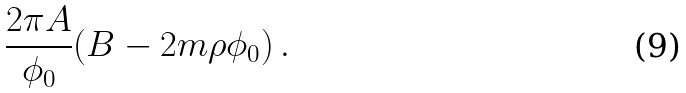Convert formula to latex. <formula><loc_0><loc_0><loc_500><loc_500>\frac { 2 \pi A } { \phi _ { 0 } } ( B - 2 m \rho \phi _ { 0 } ) \, .</formula> 